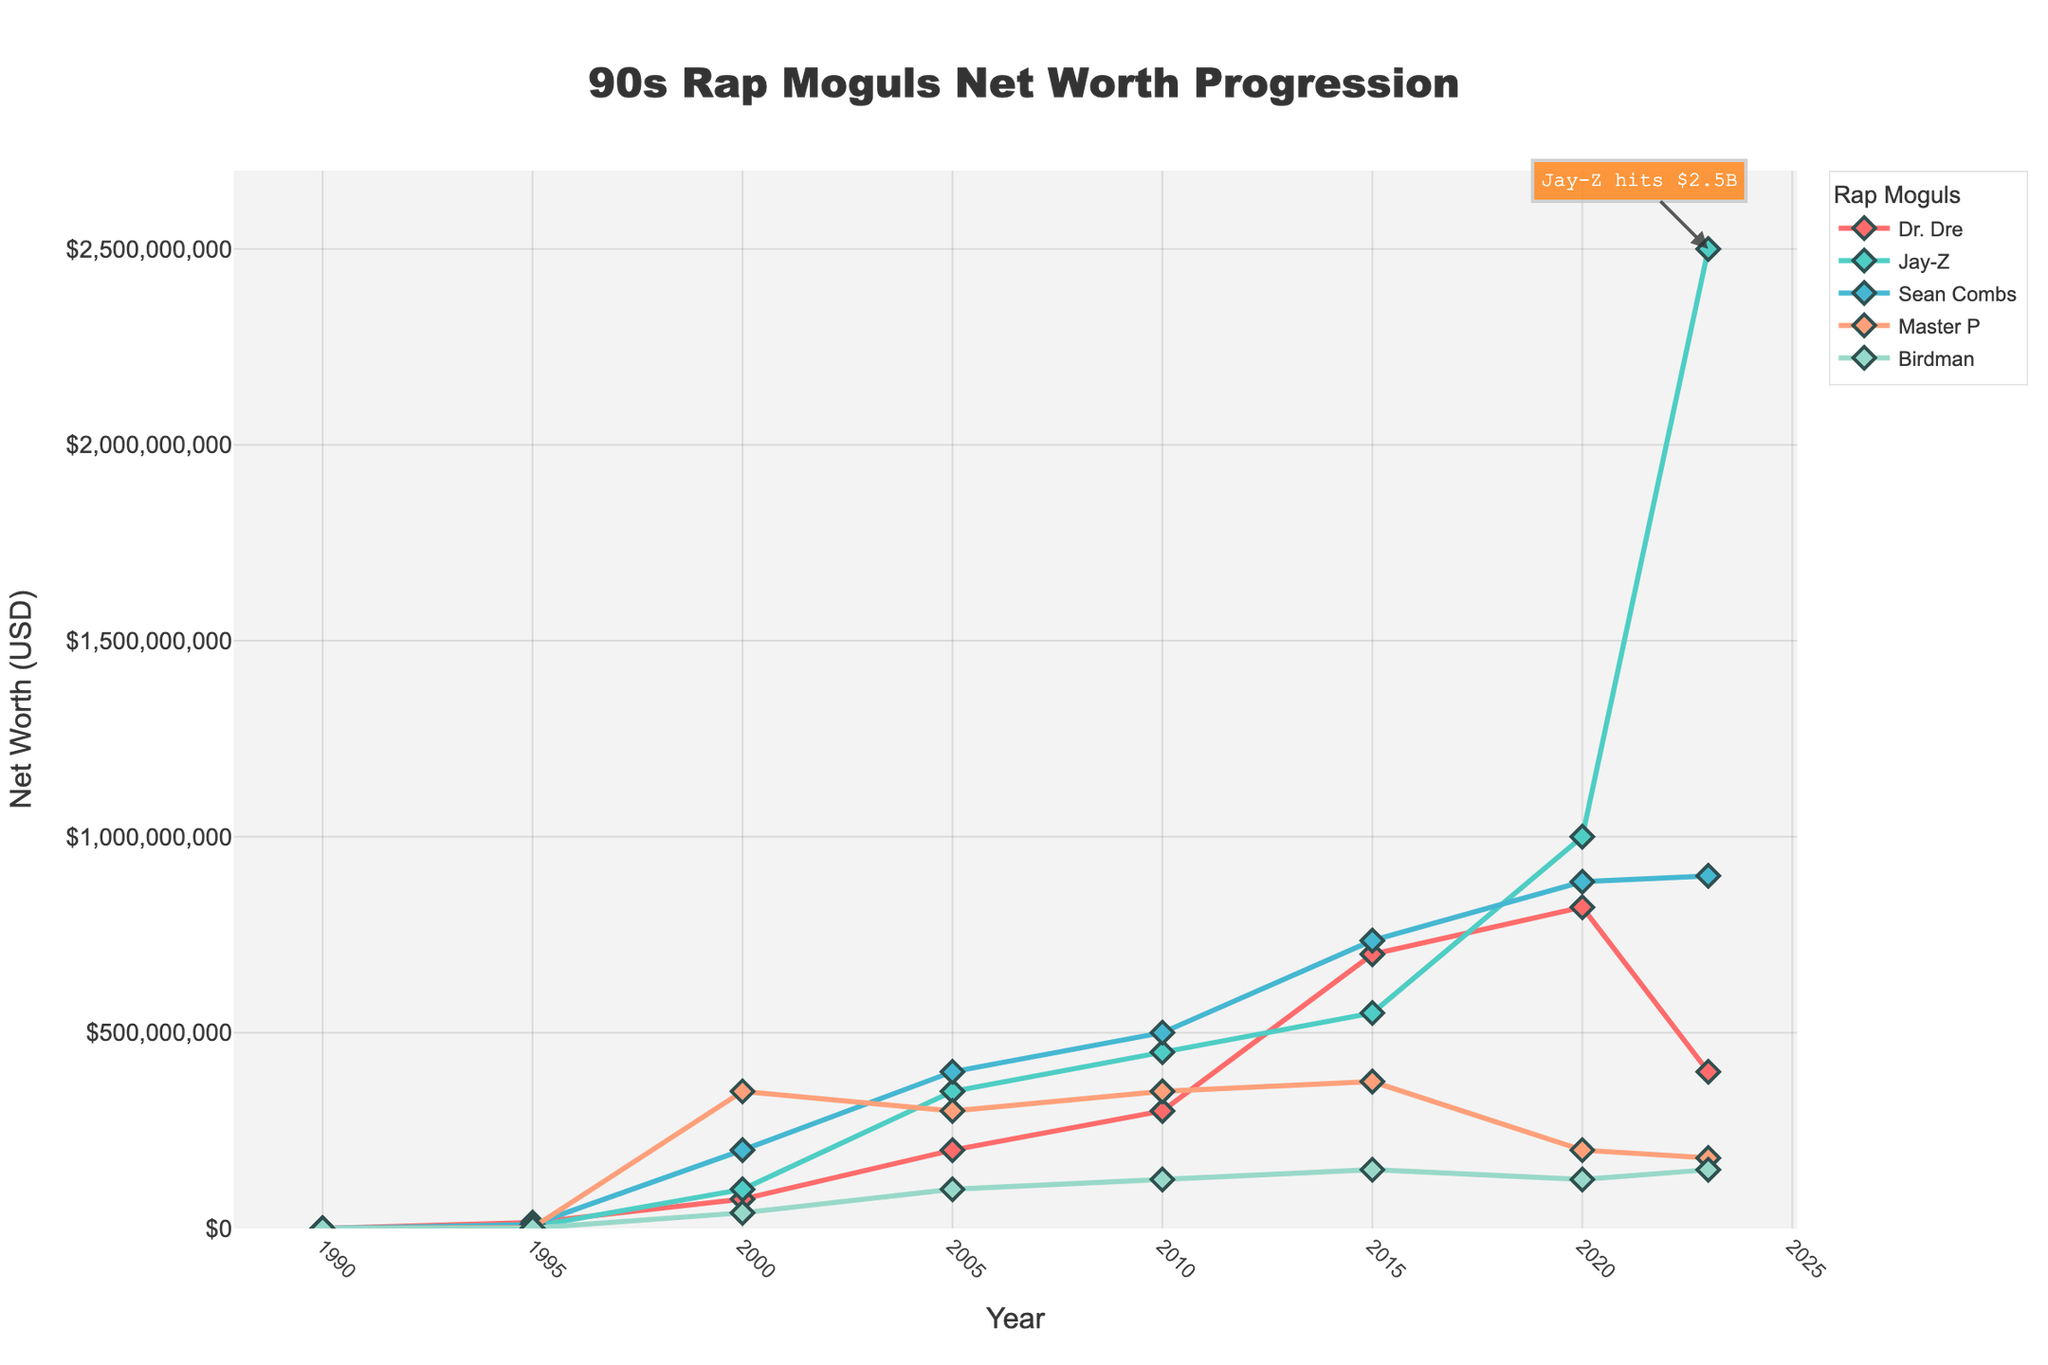What's the net worth difference between Dr. Dre and Jay-Z in 2023? In 2023, Dr. Dre's net worth is $400,000,000 and Jay-Z's net worth is $2,500,000,000. The difference is calculated as $2,500,000,000 - $400,000,000 = $2,100,000,000.
Answer: $2,100,000,000 Which rap mogul had the highest net worth in 2020? By referring to the data, in 2020, Jay-Z had the highest net worth at $1,000,000,000.
Answer: Jay-Z What was the average net worth of Sean Combs from 1990 to 2023? The net worth of Sean Combs from 1990 to 2023 is: $75,000, $10,000,000, $200,000,000, $400,000,000, $500,000,000, $735,000,000, $885,000,000, $900,000,000. Summing these values gives $3,630,075,000. Dividing by 8 years results in an average net worth of $453,759,375.
Answer: $453,759,375 Who had the lowest net worth in 2015, and what was it? In 2015, Birdman had the lowest net worth at $150,000,000.
Answer: Birdman How many rap moguls crossed the $1 billion net worth mark by 2023? By 2023, Jay-Z has crossed the $1 billion net worth mark with $2,500,000,000. So, only Jay-Z met this milestone.
Answer: 1 What is the difference in net worth for Master P between 2000 and 2020? In 2000, Master P’s net worth was $350,000,000 and in 2020, it was $200,000,000. The difference is $350,000,000 - $200,000,000 = $150,000,000.
Answer: $150,000,000 Which two rap moguls saw their net worth increase the most between 1995 and 2005? For Dr. Dre, it's from $15,000,000 to $200,000,000 (an increase of $185,000,000). For Jay-Z, it's from $5,000,000 to $350,000,000 (an increase of $345,000,000). For Sean Combs, it's from $10,000,000 to $400,000,000 (an increase of $390,000,000). For Master P, it's from $2,000,000 to $300,000,000 (an increase of $298,000,000). For Birdman, it's from $1,000,000 to $100,000,000 (an increase of $99,000,000). The two largest increases occurred for Sean Combs and Jay-Z.
Answer: Sean Combs and Jay-Z What is the total combined net worth of all the moguls in 2023? Adding the net worth values of all the moguls in 2023: $400,000,000 (Dr. Dre) + $2,500,000,000 (Jay-Z) + $900,000,000 (Sean Combs) + $180,000,000 (Master P) + $150,000,000 (Birdman) = $4,130,000,000.
Answer: $4,130,000,000 Between which years did Birdman see his highest increase in net worth? Birdman's net worth increased from $20,000 in 1990 to $1,000,000 in 1995, an increase of $980,000. His subsequent increases are lower. Hence, 1990 to 1995 is the period with the highest increase in net worth.
Answer: 1990 to 1995 